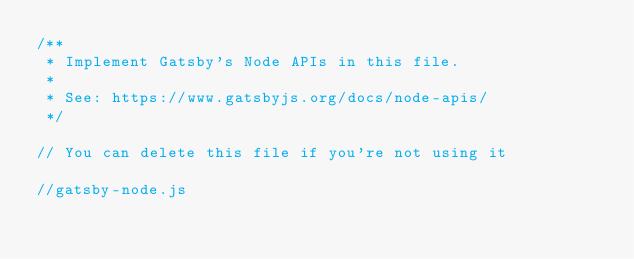Convert code to text. <code><loc_0><loc_0><loc_500><loc_500><_JavaScript_>/**
 * Implement Gatsby's Node APIs in this file.
 *
 * See: https://www.gatsbyjs.org/docs/node-apis/
 */

// You can delete this file if you're not using it

//gatsby-node.js
</code> 